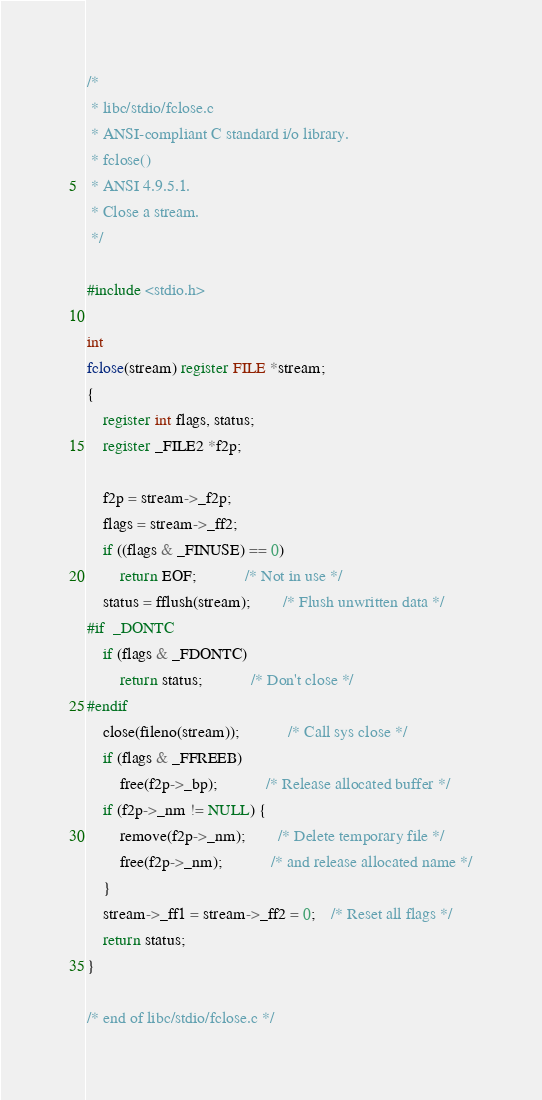<code> <loc_0><loc_0><loc_500><loc_500><_C_>/*
 * libc/stdio/fclose.c
 * ANSI-compliant C standard i/o library.
 * fclose()
 * ANSI 4.9.5.1.
 * Close a stream.
 */

#include <stdio.h>

int
fclose(stream) register FILE *stream;
{
	register int flags, status;
	register _FILE2 *f2p;

	f2p = stream->_f2p;
	flags = stream->_ff2;
	if ((flags & _FINUSE) == 0)
		return EOF;			/* Not in use */
	status = fflush(stream);		/* Flush unwritten data */
#if	_DONTC
	if (flags & _FDONTC)
		return status;			/* Don't close */
#endif
	close(fileno(stream));			/* Call sys close */
	if (flags & _FFREEB)
		free(f2p->_bp);			/* Release allocated buffer */
	if (f2p->_nm != NULL) {
		remove(f2p->_nm);		/* Delete temporary file */
		free(f2p->_nm);			/* and release allocated name */
	}
	stream->_ff1 = stream->_ff2 = 0;	/* Reset all flags */
	return status;
}

/* end of libc/stdio/fclose.c */
</code> 